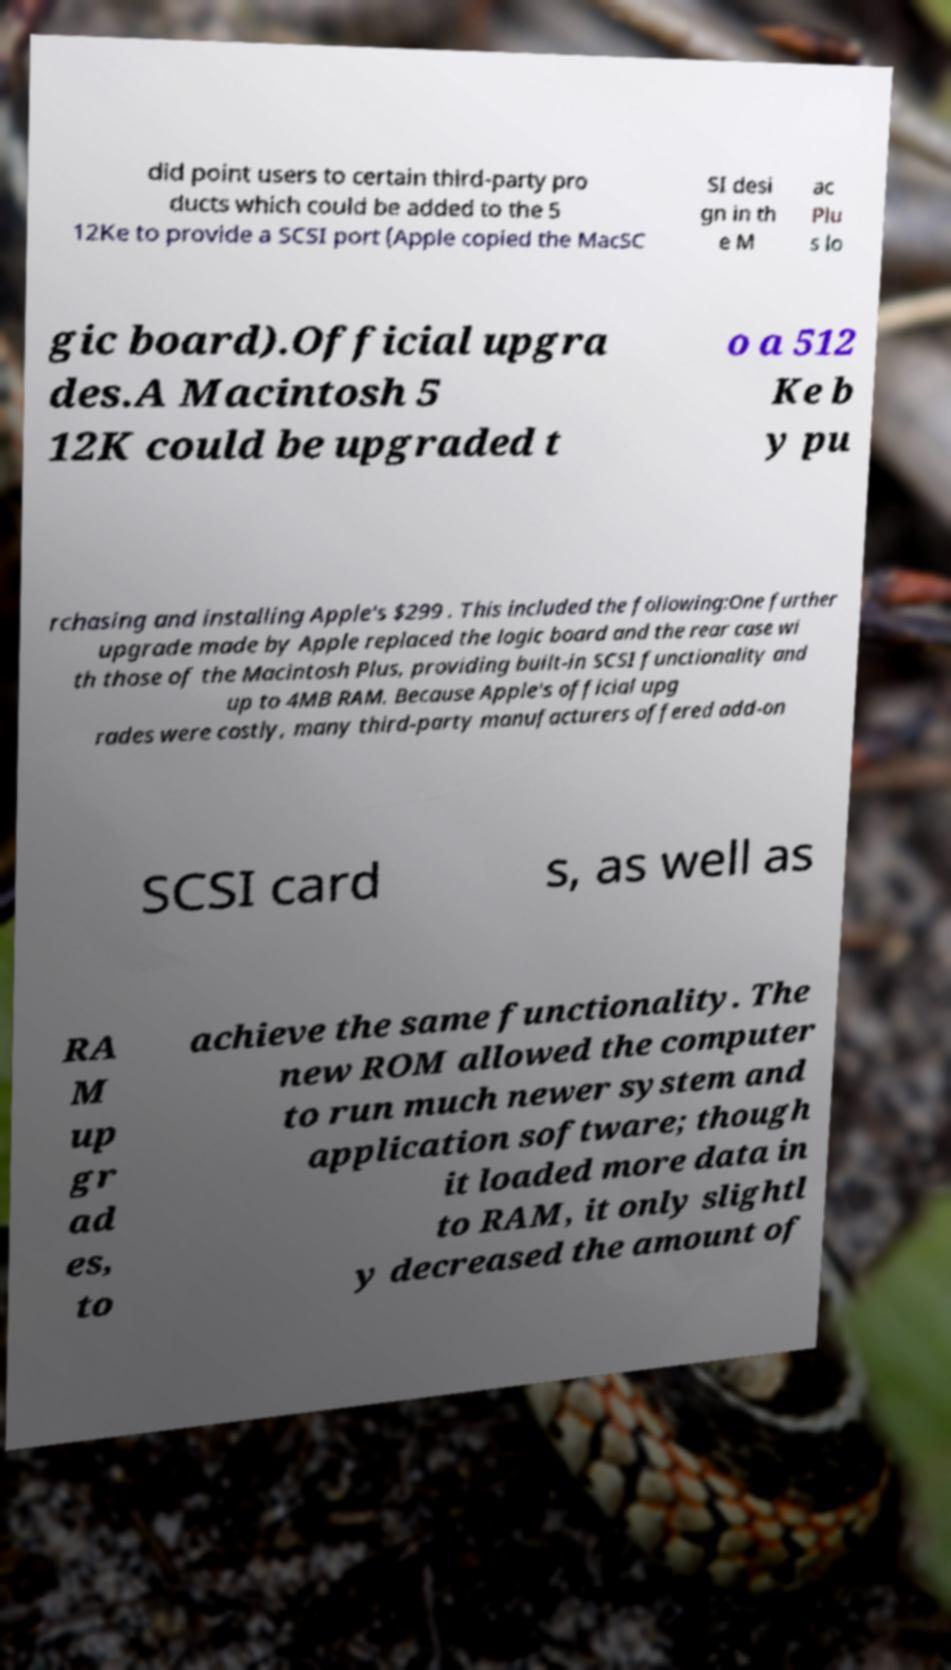What messages or text are displayed in this image? I need them in a readable, typed format. did point users to certain third-party pro ducts which could be added to the 5 12Ke to provide a SCSI port (Apple copied the MacSC SI desi gn in th e M ac Plu s lo gic board).Official upgra des.A Macintosh 5 12K could be upgraded t o a 512 Ke b y pu rchasing and installing Apple's $299 . This included the following:One further upgrade made by Apple replaced the logic board and the rear case wi th those of the Macintosh Plus, providing built-in SCSI functionality and up to 4MB RAM. Because Apple's official upg rades were costly, many third-party manufacturers offered add-on SCSI card s, as well as RA M up gr ad es, to achieve the same functionality. The new ROM allowed the computer to run much newer system and application software; though it loaded more data in to RAM, it only slightl y decreased the amount of 